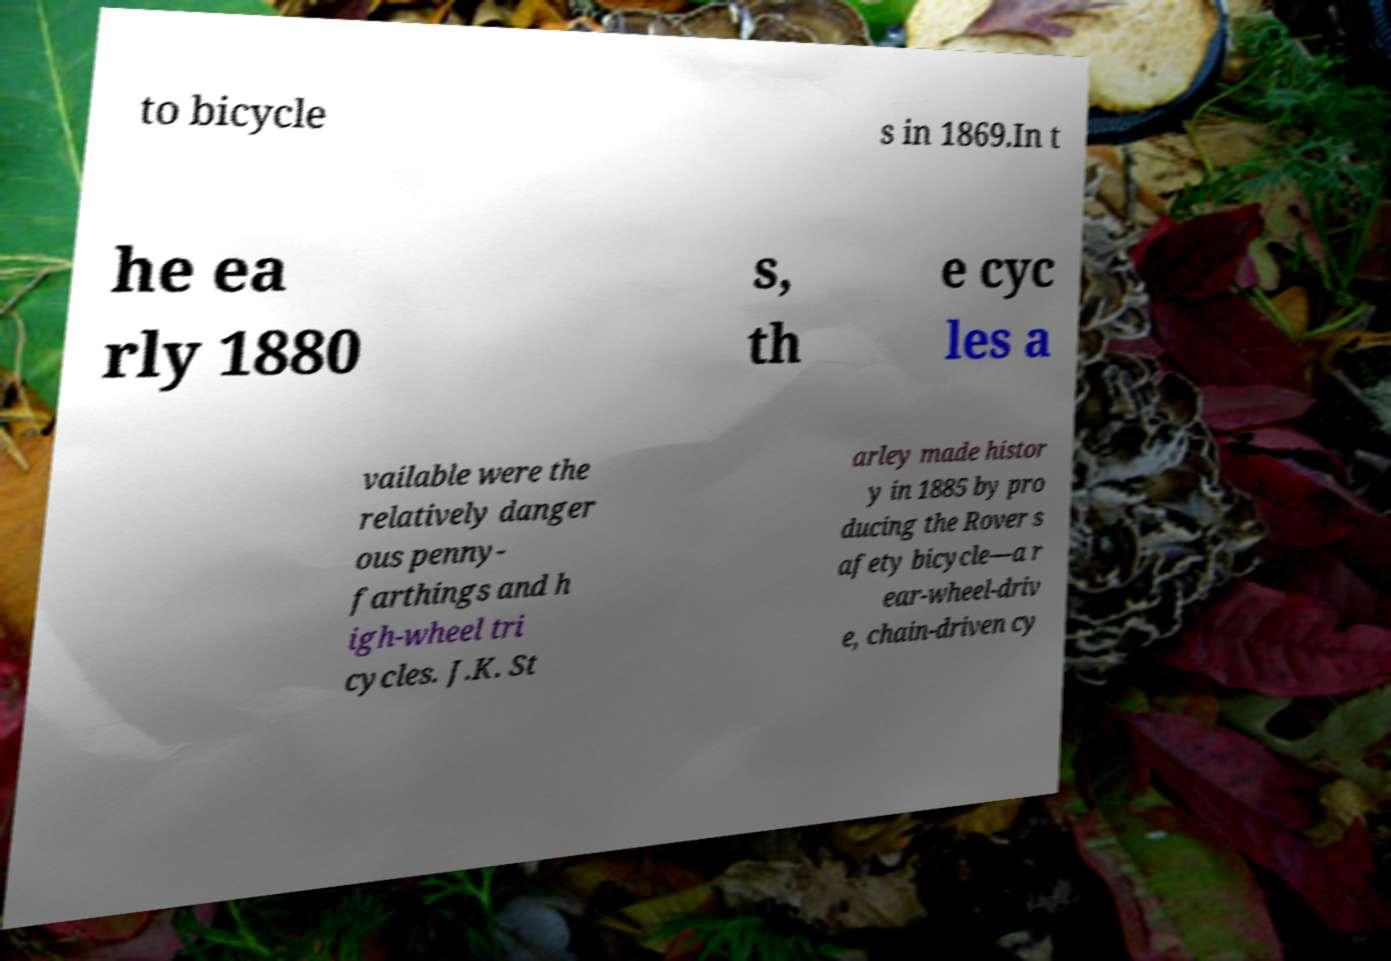Can you accurately transcribe the text from the provided image for me? to bicycle s in 1869.In t he ea rly 1880 s, th e cyc les a vailable were the relatively danger ous penny- farthings and h igh-wheel tri cycles. J.K. St arley made histor y in 1885 by pro ducing the Rover s afety bicycle—a r ear-wheel-driv e, chain-driven cy 